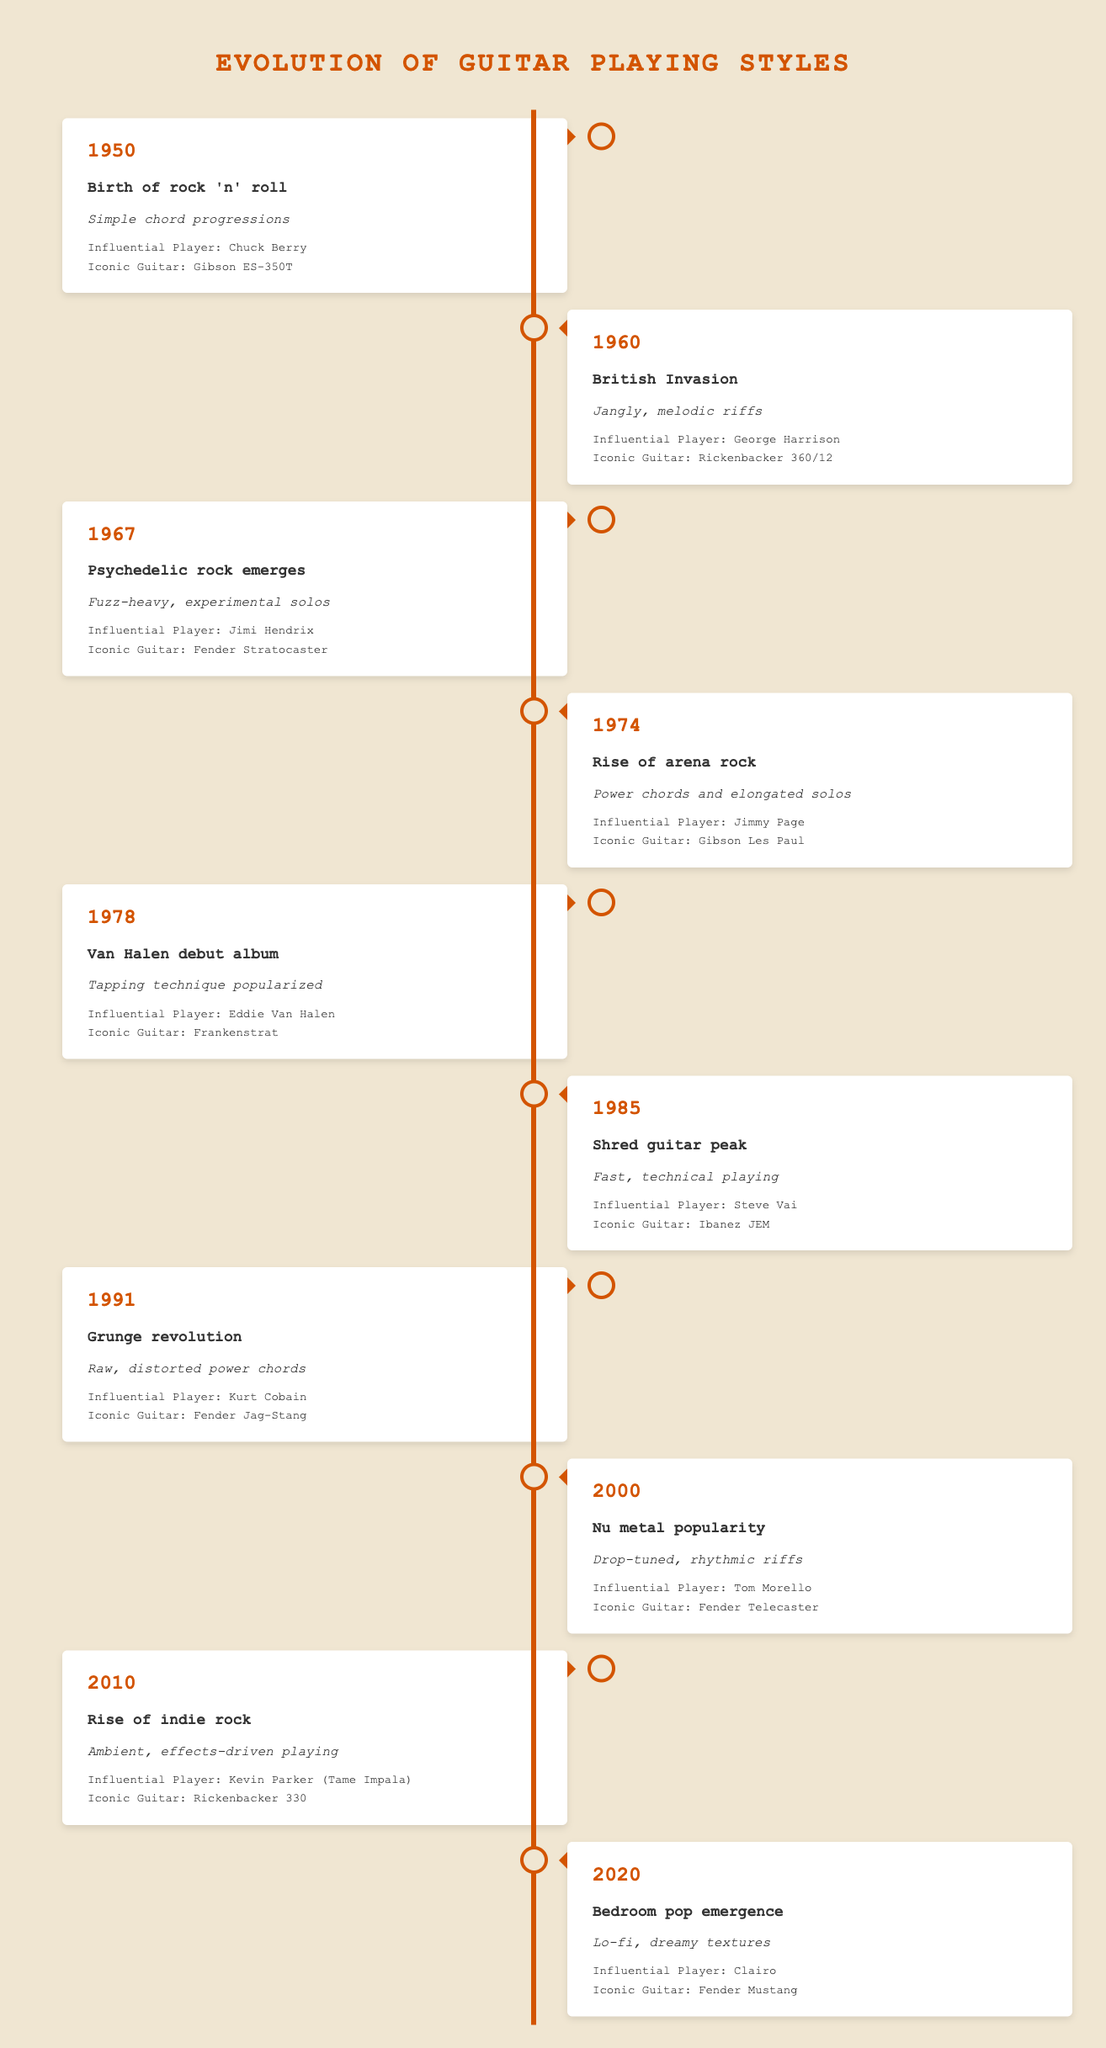What guitar was iconic during the rise of arena rock in 1974? In the timeline, the rise of arena rock is noted in the year 1974, where Jimmy Page is listed as the influential player. The iconic guitar for this event is specified as the Gibson Les Paul.
Answer: Gibson Les Paul Which player is associated with the Jangly, melodic riffs style? The timeline shows that in 1960, during the British Invasion, George Harrison is the influential player associated with the jangly, melodic riffs style.
Answer: George Harrison Was acoustic guitar playing popularized during the psychedelic rock era? The data does not mention any influence of acoustic guitar playing during the psychedelic rock era in 1967, where Jimi Hendrix's fuzz-heavy and experimental solos are highlighted instead. Therefore, it’s reasonable to answer no to this question.
Answer: No In which decade did the grunge revolution occur, and what was the style associated with it? The table indicates that the grunge revolution occurred in the year 1991, with the associated style being raw, distorted power chords.
Answer: 1990s; raw, distorted power chords What change in guitar techniques began with the Van Halen debut album in 1978? The data states that in 1978, the Van Halen debut album popularized the tapping technique. This signifies a notable change in guitar playing techniques focusing on finger tapping.
Answer: Tapping technique popularized Which decade experienced the peak of shred guitar, and who was the influential player during that time? According to the timeline, the peak of shred guitar occurred in 1985, with Steve Vai recognized as the influential player during this era.
Answer: 1980s; Steve Vai What are the styles of guitar playing between 2010 and 2020? Between 2010 (rise of indie rock) and 2020 (bedroom pop emergence), the styles evolved from ambient, effects-driven playing to lo-fi, dreamy textures, reflecting a shift from complex techniques to smoother, more atmospheric styles.
Answer: Ambient, effects-driven; lo-fi, dreamy textures Calculate the total number of influential players mentioned from the 1950s to the 2020s. To find the total number of influential players, count the rows in the provided data. Each row indicates a distinct influential player, leading to a total of 10 players listed across the timeline from 1950 to 2020.
Answer: 10 What guitar was iconic for the bedroom pop emergence in 2020? In the timeline, it specifies that for the year 2020, during the bedroom pop emergence, the iconic guitar is the Fender Mustang.
Answer: Fender Mustang 